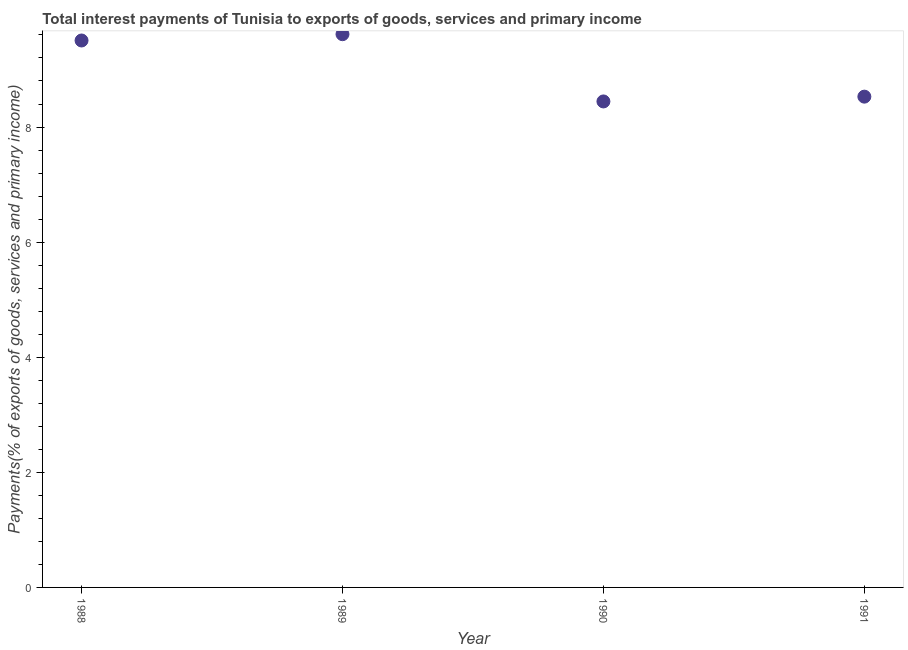What is the total interest payments on external debt in 1988?
Offer a very short reply. 9.5. Across all years, what is the maximum total interest payments on external debt?
Your answer should be very brief. 9.61. Across all years, what is the minimum total interest payments on external debt?
Offer a terse response. 8.44. In which year was the total interest payments on external debt maximum?
Give a very brief answer. 1989. What is the sum of the total interest payments on external debt?
Offer a terse response. 36.09. What is the difference between the total interest payments on external debt in 1989 and 1990?
Offer a terse response. 1.17. What is the average total interest payments on external debt per year?
Offer a very short reply. 9.02. What is the median total interest payments on external debt?
Provide a succinct answer. 9.02. In how many years, is the total interest payments on external debt greater than 8 %?
Your answer should be very brief. 4. What is the ratio of the total interest payments on external debt in 1990 to that in 1991?
Your response must be concise. 0.99. What is the difference between the highest and the second highest total interest payments on external debt?
Offer a very short reply. 0.11. What is the difference between the highest and the lowest total interest payments on external debt?
Make the answer very short. 1.17. In how many years, is the total interest payments on external debt greater than the average total interest payments on external debt taken over all years?
Keep it short and to the point. 2. How many years are there in the graph?
Provide a short and direct response. 4. Does the graph contain any zero values?
Make the answer very short. No. Does the graph contain grids?
Your answer should be compact. No. What is the title of the graph?
Your answer should be compact. Total interest payments of Tunisia to exports of goods, services and primary income. What is the label or title of the X-axis?
Offer a terse response. Year. What is the label or title of the Y-axis?
Your response must be concise. Payments(% of exports of goods, services and primary income). What is the Payments(% of exports of goods, services and primary income) in 1988?
Provide a short and direct response. 9.5. What is the Payments(% of exports of goods, services and primary income) in 1989?
Provide a short and direct response. 9.61. What is the Payments(% of exports of goods, services and primary income) in 1990?
Offer a terse response. 8.44. What is the Payments(% of exports of goods, services and primary income) in 1991?
Offer a very short reply. 8.53. What is the difference between the Payments(% of exports of goods, services and primary income) in 1988 and 1989?
Your answer should be very brief. -0.11. What is the difference between the Payments(% of exports of goods, services and primary income) in 1988 and 1990?
Provide a succinct answer. 1.06. What is the difference between the Payments(% of exports of goods, services and primary income) in 1988 and 1991?
Your response must be concise. 0.98. What is the difference between the Payments(% of exports of goods, services and primary income) in 1989 and 1990?
Offer a terse response. 1.17. What is the difference between the Payments(% of exports of goods, services and primary income) in 1989 and 1991?
Your response must be concise. 1.09. What is the difference between the Payments(% of exports of goods, services and primary income) in 1990 and 1991?
Your answer should be compact. -0.08. What is the ratio of the Payments(% of exports of goods, services and primary income) in 1988 to that in 1991?
Ensure brevity in your answer.  1.11. What is the ratio of the Payments(% of exports of goods, services and primary income) in 1989 to that in 1990?
Offer a very short reply. 1.14. What is the ratio of the Payments(% of exports of goods, services and primary income) in 1989 to that in 1991?
Your response must be concise. 1.13. 